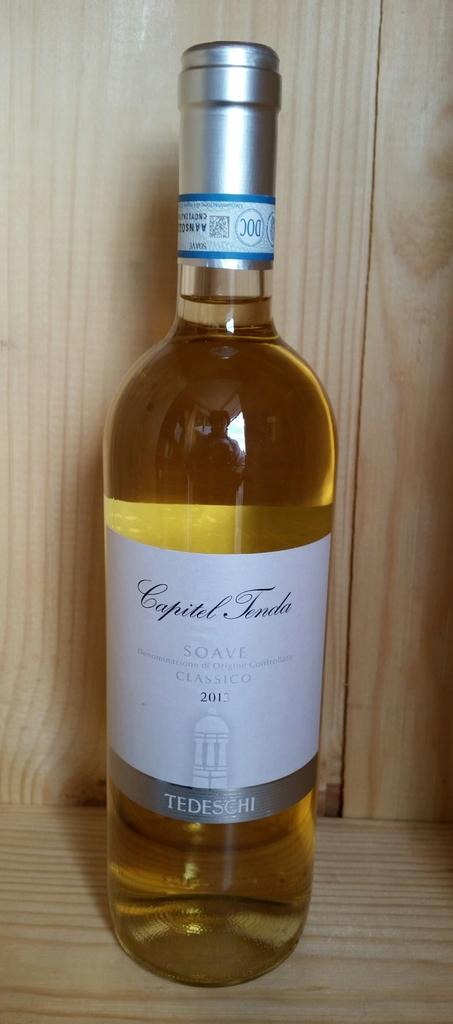What is the brand of the alcoholic beverage?
Your response must be concise. Capitel tenda. What year is the wine?
Provide a succinct answer. 2013. 